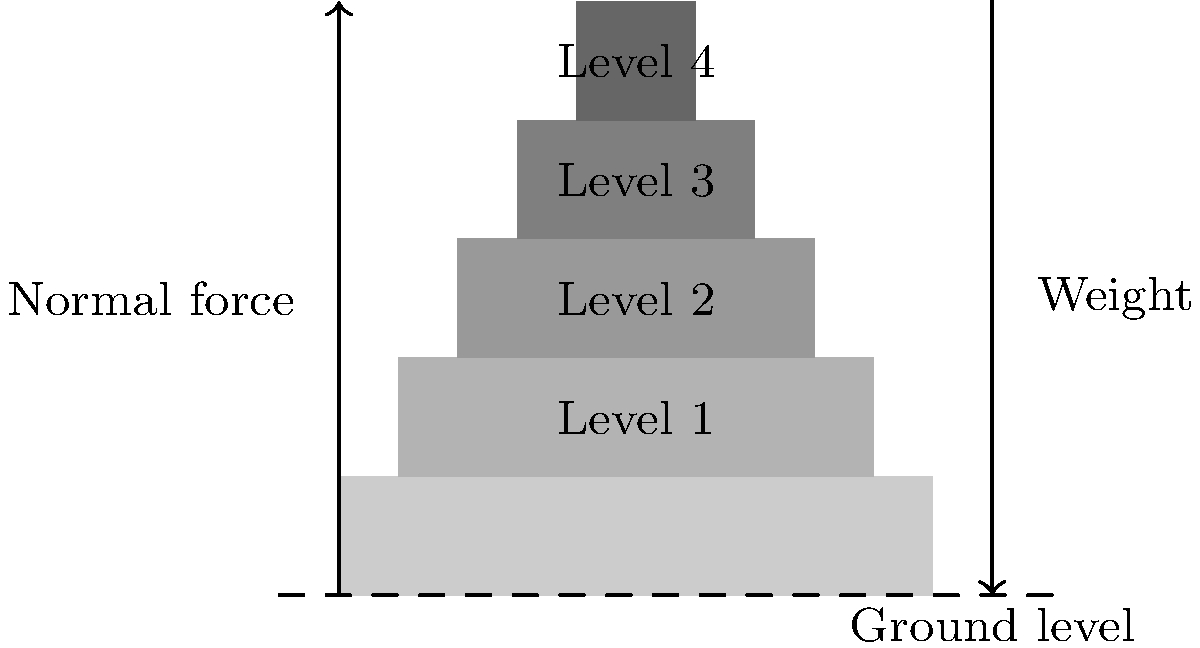Based on the cross-sectional diagram of an Assyrian ziggurat, calculate the ratio of the base width to the top level width. How does this structural design contribute to the ziggurat's stability, particularly in relation to the distribution of weight and resistance to lateral forces? To answer this question, let's analyze the diagram and follow these steps:

1. Measure the widths:
   Base width = 10 units
   Top level (Level 4) width = 2 units (10 - 4 * 2, as each level decreases by 1 unit on each side)

2. Calculate the ratio:
   Ratio = Base width : Top level width
   $$ \text{Ratio} = \frac{10}{2} = 5:1 $$

3. Structural stability analysis:
   a) Weight distribution: The stepped design distributes the weight progressively, with each level supporting less weight than the one below. This creates a stable load path to the ground.
   
   b) Center of gravity: The wider base lowers the center of gravity, increasing overall stability.
   
   c) Resistance to lateral forces: The sloped sides and wide base provide better resistance to horizontal forces (e.g., wind, earthquakes) compared to a vertical structure.
   
   d) Stress distribution: The stepped design helps distribute stress more evenly across the structure, reducing the likelihood of structural failure.

4. Mathematical representation:
   If we consider the lateral force resistance, it can be roughly approximated by the angle of the slope. The arctangent of the height-to-width ratio gives us this angle:
   
   $$ \theta = \arctan(\frac{\text{Height}}{\frac{1}{2}(\text{Base width - Top width})}) = \arctan(\frac{8}{\frac{1}{2}(10-2)}) \approx 63.4° $$

   This steep angle provides significant resistance to lateral forces while maintaining structural integrity.
Answer: 5:1 ratio; stepped design distributes weight, lowers center of gravity, and resists lateral forces. 